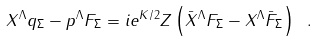Convert formula to latex. <formula><loc_0><loc_0><loc_500><loc_500>X ^ { \Lambda } q _ { \Sigma } - p ^ { \Lambda } F _ { \Sigma } = i e ^ { K / 2 } Z \left ( { \bar { X } } ^ { \Lambda } F _ { \Sigma } - { X } ^ { \Lambda } { \bar { F } } _ { \Sigma } \right ) \ .</formula> 